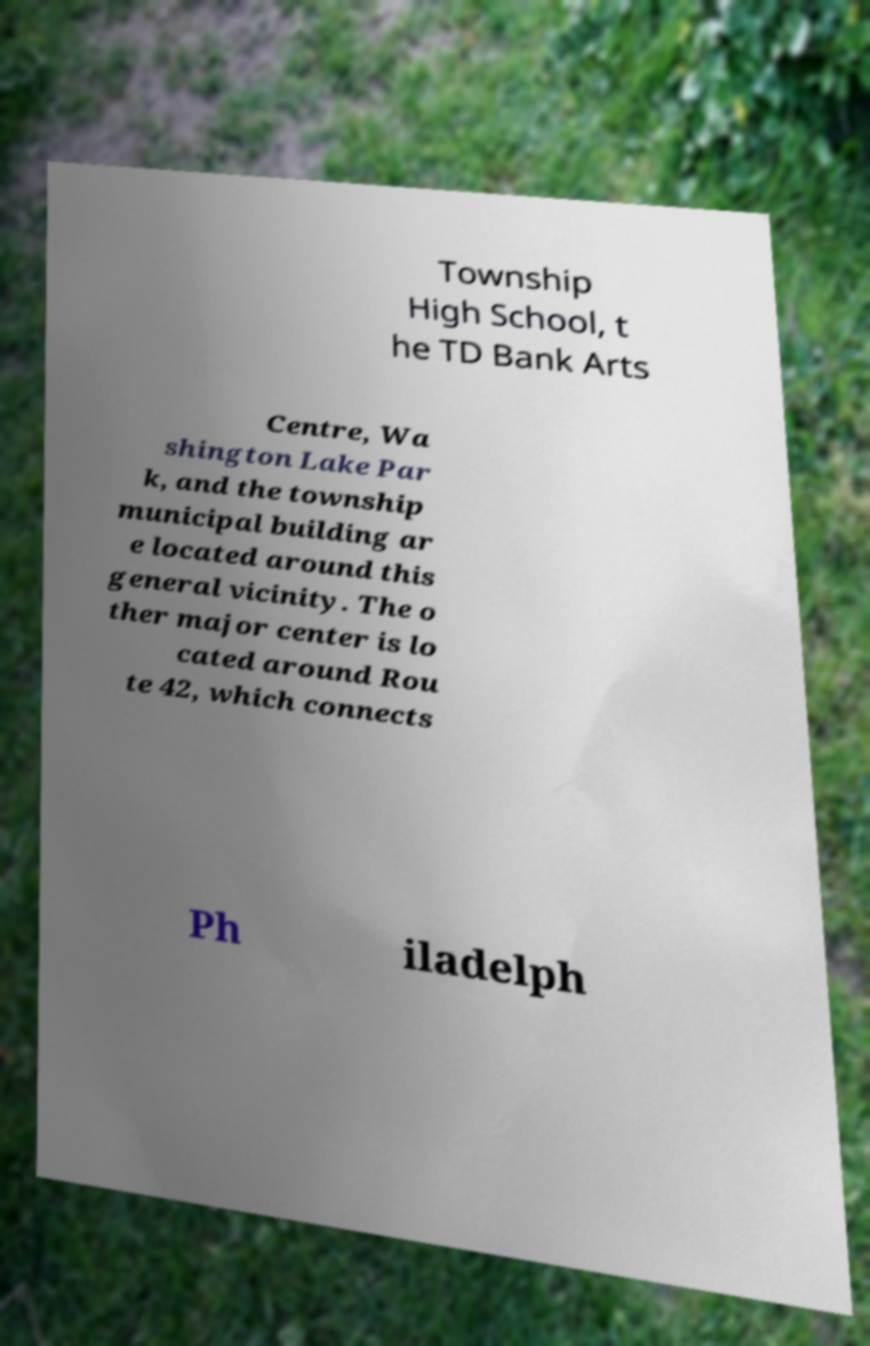Could you assist in decoding the text presented in this image and type it out clearly? Township High School, t he TD Bank Arts Centre, Wa shington Lake Par k, and the township municipal building ar e located around this general vicinity. The o ther major center is lo cated around Rou te 42, which connects Ph iladelph 